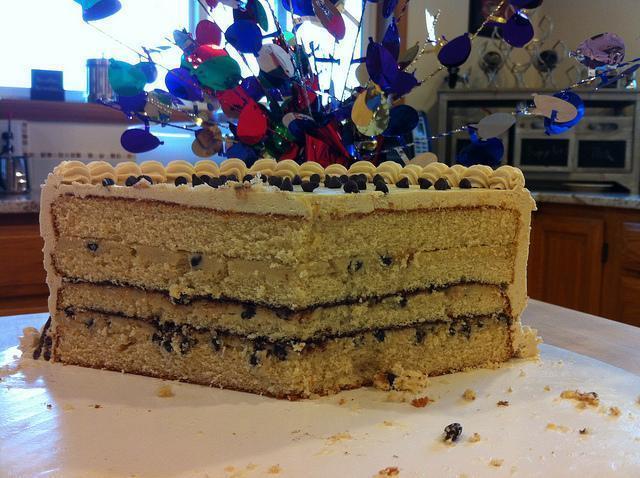Is the given caption "The oven is beneath the cake." fitting for the image?
Answer yes or no. No. 